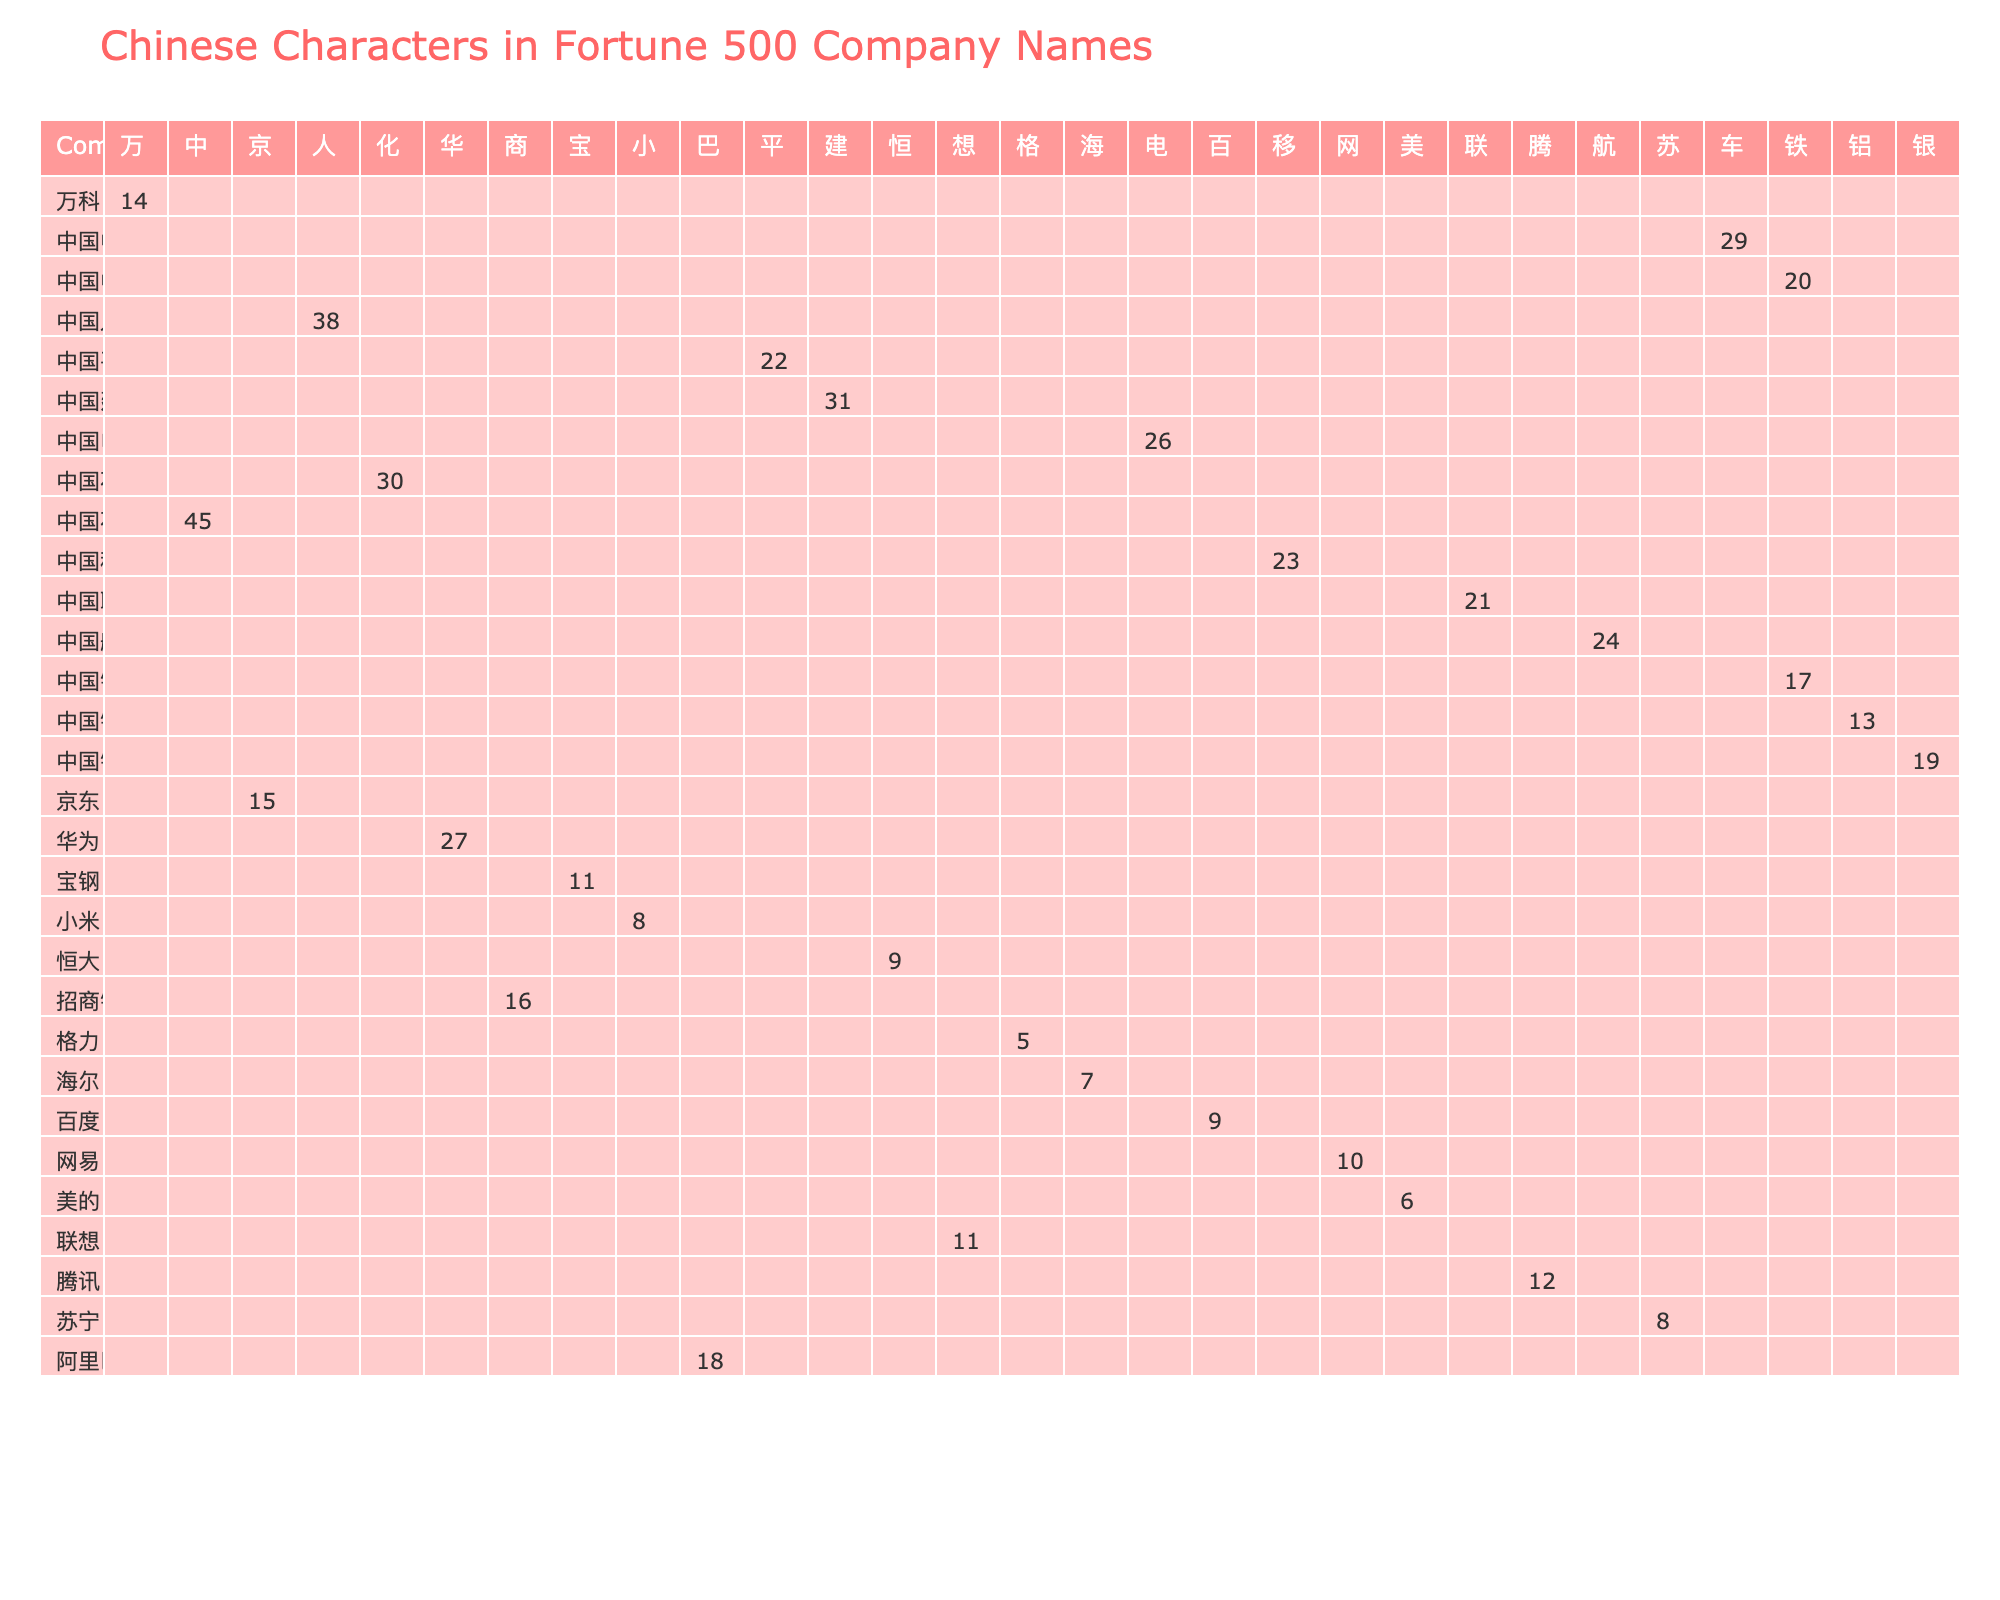What is the frequency of the character "华" in the company names? The table shows that the character "华" appears in the company name "华为" with a frequency of 27.
Answer: 27 Which character has the highest frequency in the table? By checking the frequency values, we find that the character "中" from "中国石油" has the highest frequency of 45.
Answer: 中 How many companies use the character "铁"? There are two companies that use the character "铁": "中国铁建" and "中国中铁."
Answer: 2 What is the sum of frequencies of the characters used in "中国" and "阿里巴巴"? The characters from "中国" are "中" (45) and "国" (0). The character from "阿里巴巴" is "巴" (18). So, the sum is 45 + 0 + 18 = 63.
Answer: 63 Does the character "电" have a frequency greater than 20? The character "电" appears in "中国电信" with a frequency of 26, which is greater than 20.
Answer: Yes What is the average frequency of characters from the company names that contain "中国"? The frequencies for characters from "中国" are: "中" (45), "国" (0), "移" (23), "建" (31), "银" (19), "平" (22), totaling 140. There are 7 entries, so the average is 140/7 ≈ 20.
Answer: 20 Which character has the lowest frequency, and how many times does it appear? The character "格" from "格力" has the lowest frequency, appearing 5 times.
Answer: 格, 5 How many characters have a frequency of 10 or greater? By counting the frequencies in the table, the characters with a frequency of 10 or greater are: "中," "华," "移," "建," "银," "平," "巴," "商," "电," "联," "航," "化," which total 12 characters.
Answer: 12 What is the difference in frequency between the character "人" and "小"? The frequency of "人" is 38, and for "小" it is 8. The difference is 38 - 8 = 30.
Answer: 30 Are there more characters with frequencies less than 10 than those with greater than or equal to 10? There are 5 characters with frequencies less than 10 (海, 美, 小, 格, 苏) and 18 characters with frequencies greater than or equal to 10. Thus, there are more characters with frequencies greater than or equal to 10.
Answer: No 